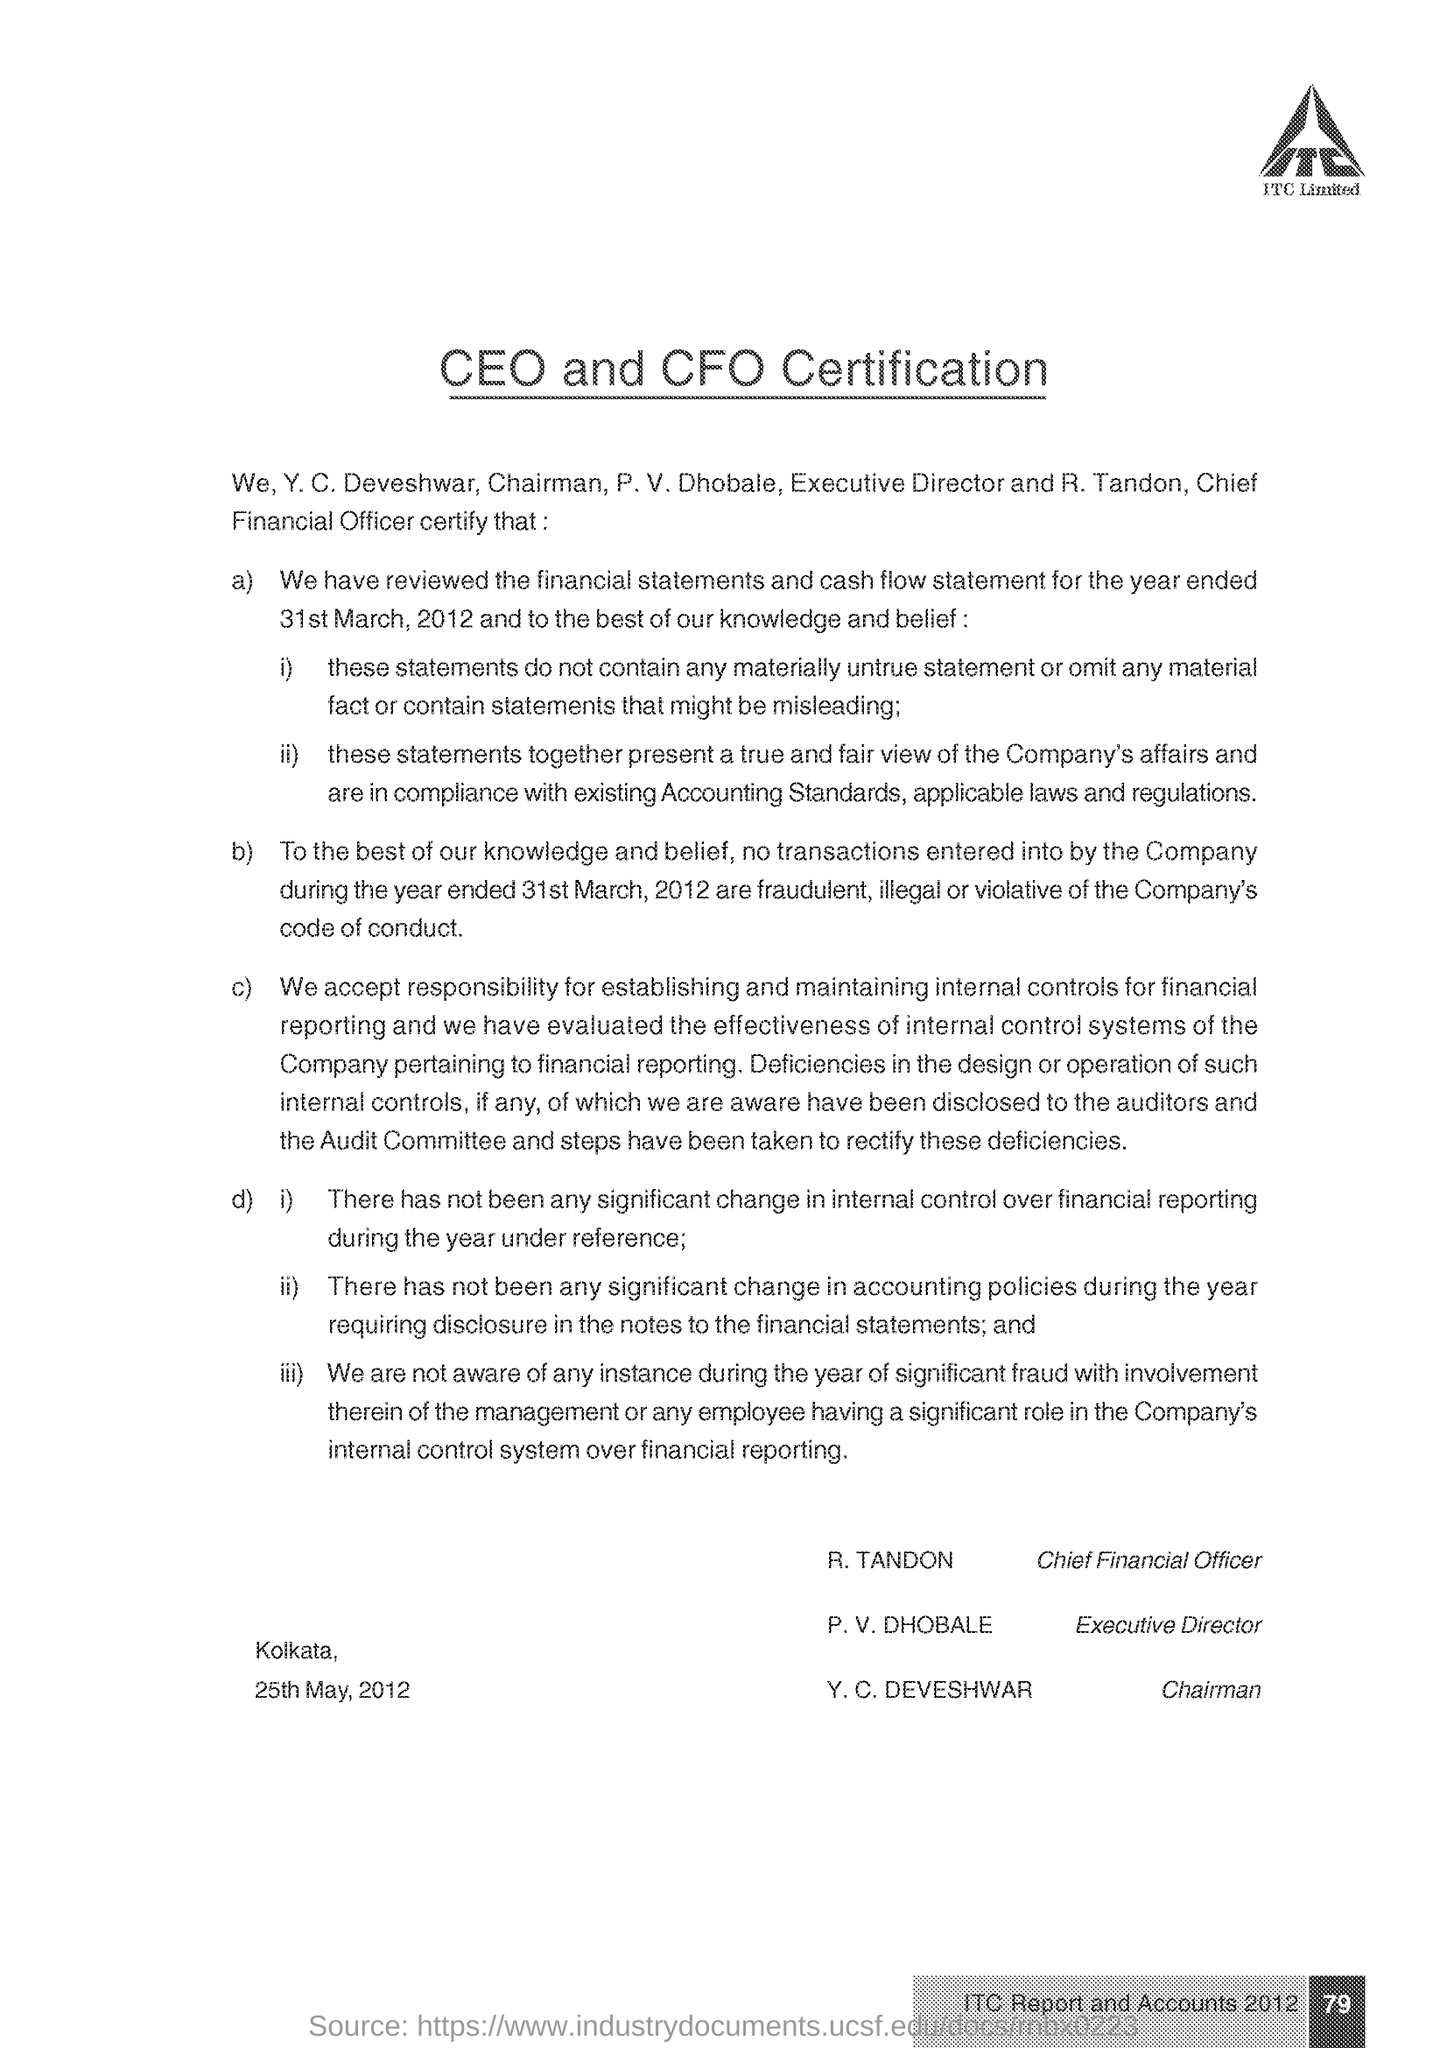What certification is given here?
Make the answer very short. CEO and CFO Certification. What is the designation of Y. C. Deveshwar?
Provide a short and direct response. Chairman. What is the designation of P. V. Dhobale?
Your response must be concise. Executive Director. What is the page no mentioned in this document?
Your answer should be compact. 79. 